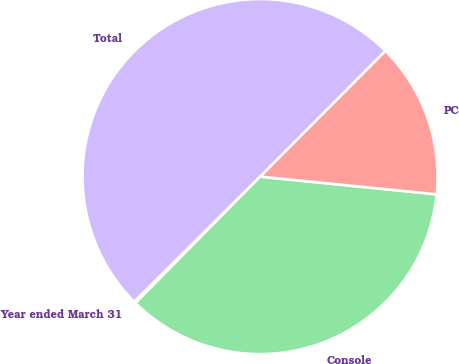Convert chart to OTSL. <chart><loc_0><loc_0><loc_500><loc_500><pie_chart><fcel>Year ended March 31<fcel>Console<fcel>PC<fcel>Total<nl><fcel>0.17%<fcel>35.79%<fcel>14.12%<fcel>49.91%<nl></chart> 